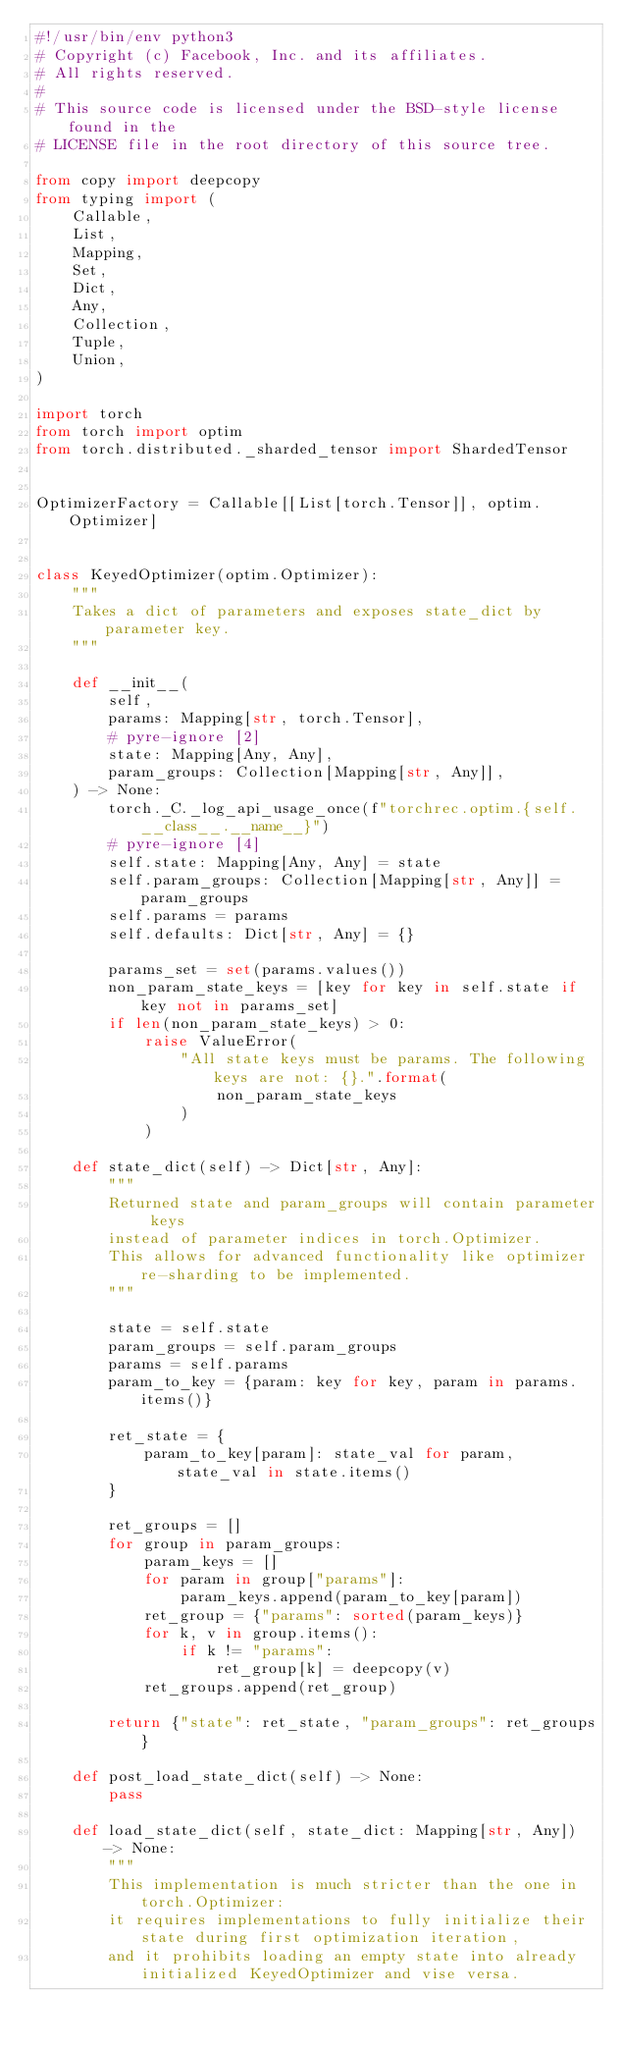Convert code to text. <code><loc_0><loc_0><loc_500><loc_500><_Python_>#!/usr/bin/env python3
# Copyright (c) Facebook, Inc. and its affiliates.
# All rights reserved.
#
# This source code is licensed under the BSD-style license found in the
# LICENSE file in the root directory of this source tree.

from copy import deepcopy
from typing import (
    Callable,
    List,
    Mapping,
    Set,
    Dict,
    Any,
    Collection,
    Tuple,
    Union,
)

import torch
from torch import optim
from torch.distributed._sharded_tensor import ShardedTensor


OptimizerFactory = Callable[[List[torch.Tensor]], optim.Optimizer]


class KeyedOptimizer(optim.Optimizer):
    """
    Takes a dict of parameters and exposes state_dict by parameter key.
    """

    def __init__(
        self,
        params: Mapping[str, torch.Tensor],
        # pyre-ignore [2]
        state: Mapping[Any, Any],
        param_groups: Collection[Mapping[str, Any]],
    ) -> None:
        torch._C._log_api_usage_once(f"torchrec.optim.{self.__class__.__name__}")
        # pyre-ignore [4]
        self.state: Mapping[Any, Any] = state
        self.param_groups: Collection[Mapping[str, Any]] = param_groups
        self.params = params
        self.defaults: Dict[str, Any] = {}

        params_set = set(params.values())
        non_param_state_keys = [key for key in self.state if key not in params_set]
        if len(non_param_state_keys) > 0:
            raise ValueError(
                "All state keys must be params. The following keys are not: {}.".format(
                    non_param_state_keys
                )
            )

    def state_dict(self) -> Dict[str, Any]:
        """
        Returned state and param_groups will contain parameter keys
        instead of parameter indices in torch.Optimizer.
        This allows for advanced functionality like optimizer re-sharding to be implemented.
        """

        state = self.state
        param_groups = self.param_groups
        params = self.params
        param_to_key = {param: key for key, param in params.items()}

        ret_state = {
            param_to_key[param]: state_val for param, state_val in state.items()
        }

        ret_groups = []
        for group in param_groups:
            param_keys = []
            for param in group["params"]:
                param_keys.append(param_to_key[param])
            ret_group = {"params": sorted(param_keys)}
            for k, v in group.items():
                if k != "params":
                    ret_group[k] = deepcopy(v)
            ret_groups.append(ret_group)

        return {"state": ret_state, "param_groups": ret_groups}

    def post_load_state_dict(self) -> None:
        pass

    def load_state_dict(self, state_dict: Mapping[str, Any]) -> None:
        """
        This implementation is much stricter than the one in torch.Optimizer:
        it requires implementations to fully initialize their state during first optimization iteration,
        and it prohibits loading an empty state into already initialized KeyedOptimizer and vise versa.</code> 